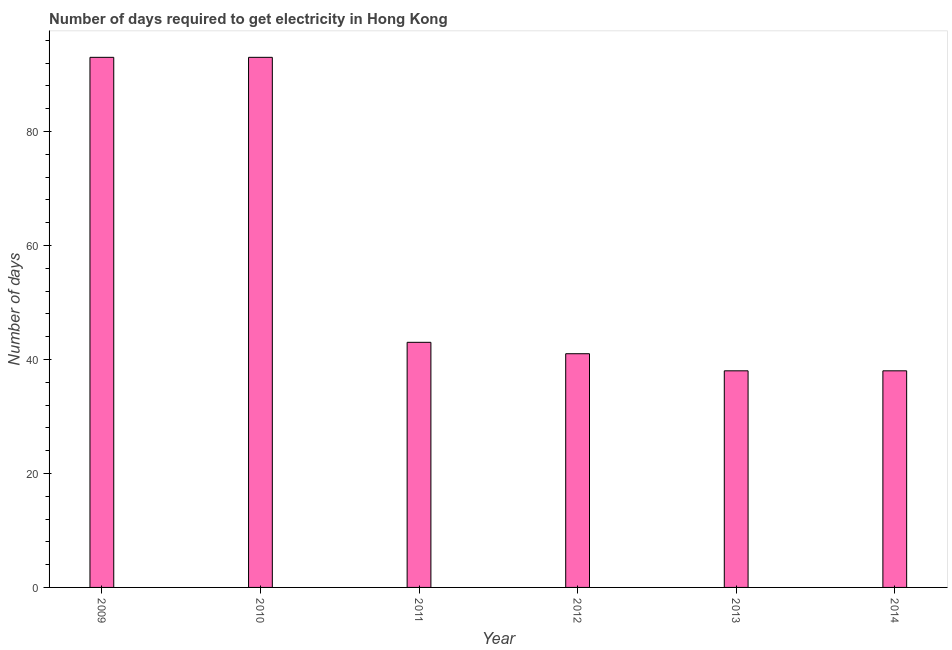Does the graph contain any zero values?
Offer a terse response. No. Does the graph contain grids?
Your answer should be very brief. No. What is the title of the graph?
Keep it short and to the point. Number of days required to get electricity in Hong Kong. What is the label or title of the Y-axis?
Offer a terse response. Number of days. What is the time to get electricity in 2009?
Give a very brief answer. 93. Across all years, what is the maximum time to get electricity?
Make the answer very short. 93. In which year was the time to get electricity maximum?
Make the answer very short. 2009. In which year was the time to get electricity minimum?
Keep it short and to the point. 2013. What is the sum of the time to get electricity?
Offer a very short reply. 346. What is the median time to get electricity?
Ensure brevity in your answer.  42. In how many years, is the time to get electricity greater than 4 ?
Make the answer very short. 6. What is the ratio of the time to get electricity in 2010 to that in 2013?
Make the answer very short. 2.45. Is the difference between the time to get electricity in 2010 and 2014 greater than the difference between any two years?
Your response must be concise. Yes. What is the difference between the highest and the second highest time to get electricity?
Make the answer very short. 0. What is the difference between the highest and the lowest time to get electricity?
Your answer should be compact. 55. Are all the bars in the graph horizontal?
Give a very brief answer. No. What is the Number of days of 2009?
Make the answer very short. 93. What is the Number of days in 2010?
Offer a terse response. 93. What is the Number of days of 2012?
Ensure brevity in your answer.  41. What is the difference between the Number of days in 2009 and 2010?
Offer a very short reply. 0. What is the difference between the Number of days in 2009 and 2011?
Your response must be concise. 50. What is the difference between the Number of days in 2009 and 2014?
Your answer should be very brief. 55. What is the difference between the Number of days in 2010 and 2012?
Your answer should be very brief. 52. What is the difference between the Number of days in 2010 and 2014?
Keep it short and to the point. 55. What is the difference between the Number of days in 2011 and 2013?
Give a very brief answer. 5. What is the difference between the Number of days in 2012 and 2014?
Offer a very short reply. 3. What is the ratio of the Number of days in 2009 to that in 2010?
Provide a succinct answer. 1. What is the ratio of the Number of days in 2009 to that in 2011?
Give a very brief answer. 2.16. What is the ratio of the Number of days in 2009 to that in 2012?
Provide a short and direct response. 2.27. What is the ratio of the Number of days in 2009 to that in 2013?
Provide a succinct answer. 2.45. What is the ratio of the Number of days in 2009 to that in 2014?
Give a very brief answer. 2.45. What is the ratio of the Number of days in 2010 to that in 2011?
Your response must be concise. 2.16. What is the ratio of the Number of days in 2010 to that in 2012?
Ensure brevity in your answer.  2.27. What is the ratio of the Number of days in 2010 to that in 2013?
Offer a very short reply. 2.45. What is the ratio of the Number of days in 2010 to that in 2014?
Give a very brief answer. 2.45. What is the ratio of the Number of days in 2011 to that in 2012?
Keep it short and to the point. 1.05. What is the ratio of the Number of days in 2011 to that in 2013?
Give a very brief answer. 1.13. What is the ratio of the Number of days in 2011 to that in 2014?
Provide a short and direct response. 1.13. What is the ratio of the Number of days in 2012 to that in 2013?
Provide a succinct answer. 1.08. What is the ratio of the Number of days in 2012 to that in 2014?
Your answer should be very brief. 1.08. 